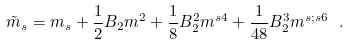<formula> <loc_0><loc_0><loc_500><loc_500>\tilde { m } _ { s } = m _ { s } + \frac { 1 } { 2 } B _ { 2 } m ^ { 2 } + \frac { 1 } { 8 } B _ { 2 } ^ { 2 } m ^ { s 4 } + \frac { 1 } { 4 8 } B _ { 2 } ^ { 3 } m ^ { s ; s 6 } \ .</formula> 